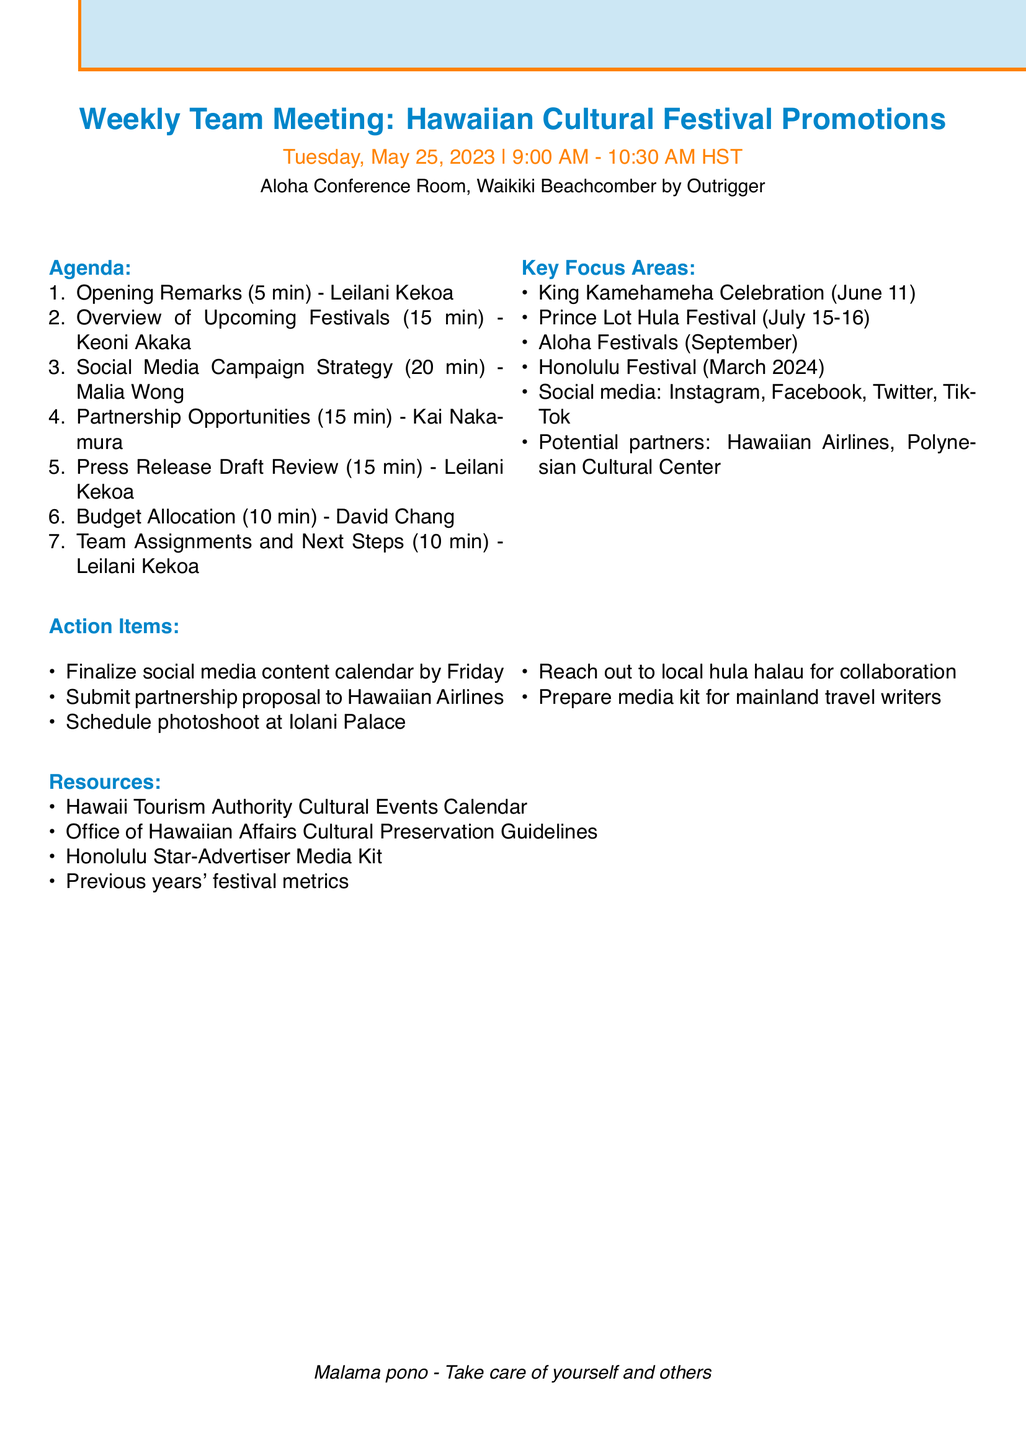What is the date of the meeting? The meeting date is specified in the document as Tuesday, May 25, 2023.
Answer: Tuesday, May 25, 2023 Who will present the overview of upcoming festivals? The presenter for the overview of upcoming festivals is indicated in the document.
Answer: Keoni Akaka How long is the social media campaign strategy item? The duration of the social media campaign strategy is clearly stated alongside the agenda item.
Answer: 20 minutes What is the focus point for the press release review? The document outlines key focus points for the press release draft review.
Answer: Highlighting unique aspects of each festival Which festival occurs on June 11? The specific festival mentioned in the document that occurs on June 11 is listed under key points.
Answer: King Kamehameha Celebration What action item is due by Friday? The action items are listed, with one due by Friday noted specifically.
Answer: Finalize social media content calendar Who is responsible for budget allocation? The document lists the presenter responsible for discussing budget allocation.
Answer: David Chang Which potential partner is mentioned for collaboration? The document lists potential partners that may be relevant for collaboration.
Answer: Hawaiian Airlines 